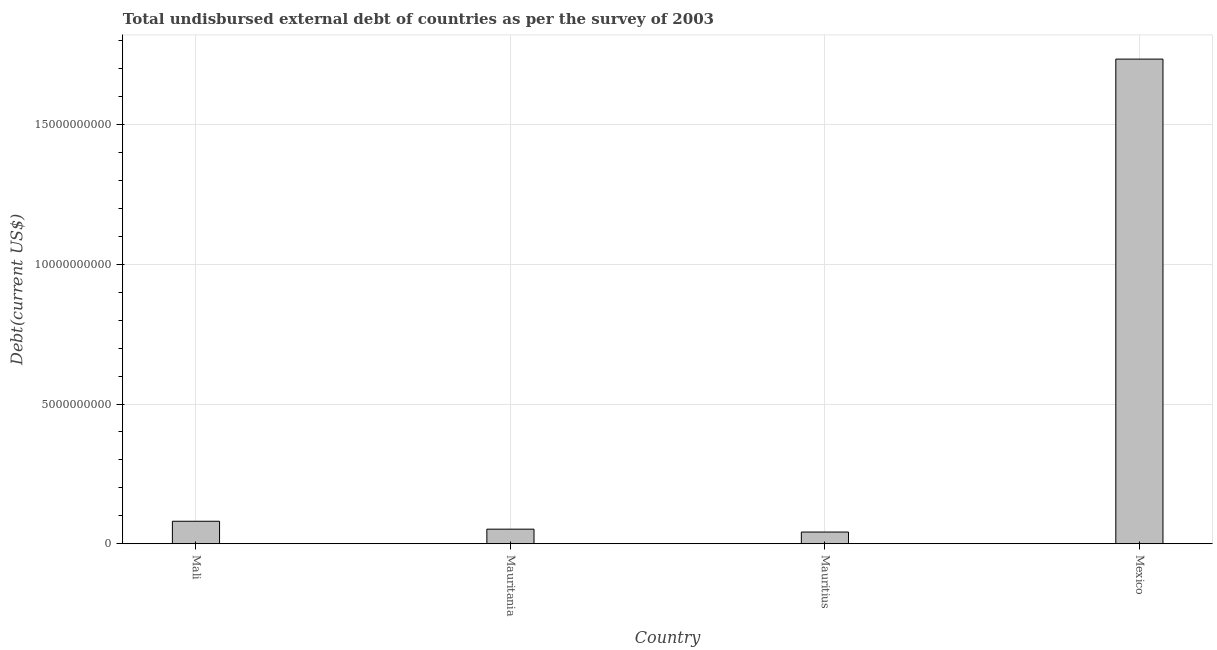What is the title of the graph?
Provide a short and direct response. Total undisbursed external debt of countries as per the survey of 2003. What is the label or title of the Y-axis?
Your response must be concise. Debt(current US$). What is the total debt in Mali?
Your answer should be compact. 8.05e+08. Across all countries, what is the maximum total debt?
Make the answer very short. 1.73e+1. Across all countries, what is the minimum total debt?
Offer a very short reply. 4.19e+08. In which country was the total debt minimum?
Your response must be concise. Mauritius. What is the sum of the total debt?
Provide a short and direct response. 1.91e+1. What is the difference between the total debt in Mauritania and Mexico?
Ensure brevity in your answer.  -1.68e+1. What is the average total debt per country?
Your response must be concise. 4.77e+09. What is the median total debt?
Offer a very short reply. 6.63e+08. In how many countries, is the total debt greater than 5000000000 US$?
Make the answer very short. 1. What is the ratio of the total debt in Mauritius to that in Mexico?
Offer a terse response. 0.02. Is the total debt in Mauritius less than that in Mexico?
Your answer should be compact. Yes. What is the difference between the highest and the second highest total debt?
Offer a terse response. 1.65e+1. Is the sum of the total debt in Mali and Mauritania greater than the maximum total debt across all countries?
Keep it short and to the point. No. What is the difference between the highest and the lowest total debt?
Your answer should be very brief. 1.69e+1. How many bars are there?
Provide a succinct answer. 4. Are all the bars in the graph horizontal?
Your answer should be compact. No. How many countries are there in the graph?
Your answer should be compact. 4. What is the difference between two consecutive major ticks on the Y-axis?
Offer a very short reply. 5.00e+09. What is the Debt(current US$) in Mali?
Provide a short and direct response. 8.05e+08. What is the Debt(current US$) of Mauritania?
Provide a short and direct response. 5.22e+08. What is the Debt(current US$) in Mauritius?
Give a very brief answer. 4.19e+08. What is the Debt(current US$) of Mexico?
Offer a very short reply. 1.73e+1. What is the difference between the Debt(current US$) in Mali and Mauritania?
Your answer should be compact. 2.83e+08. What is the difference between the Debt(current US$) in Mali and Mauritius?
Provide a short and direct response. 3.86e+08. What is the difference between the Debt(current US$) in Mali and Mexico?
Your answer should be compact. -1.65e+1. What is the difference between the Debt(current US$) in Mauritania and Mauritius?
Your answer should be very brief. 1.03e+08. What is the difference between the Debt(current US$) in Mauritania and Mexico?
Keep it short and to the point. -1.68e+1. What is the difference between the Debt(current US$) in Mauritius and Mexico?
Your answer should be compact. -1.69e+1. What is the ratio of the Debt(current US$) in Mali to that in Mauritania?
Your response must be concise. 1.54. What is the ratio of the Debt(current US$) in Mali to that in Mauritius?
Make the answer very short. 1.92. What is the ratio of the Debt(current US$) in Mali to that in Mexico?
Your answer should be very brief. 0.05. What is the ratio of the Debt(current US$) in Mauritania to that in Mauritius?
Give a very brief answer. 1.25. What is the ratio of the Debt(current US$) in Mauritania to that in Mexico?
Your response must be concise. 0.03. What is the ratio of the Debt(current US$) in Mauritius to that in Mexico?
Make the answer very short. 0.02. 